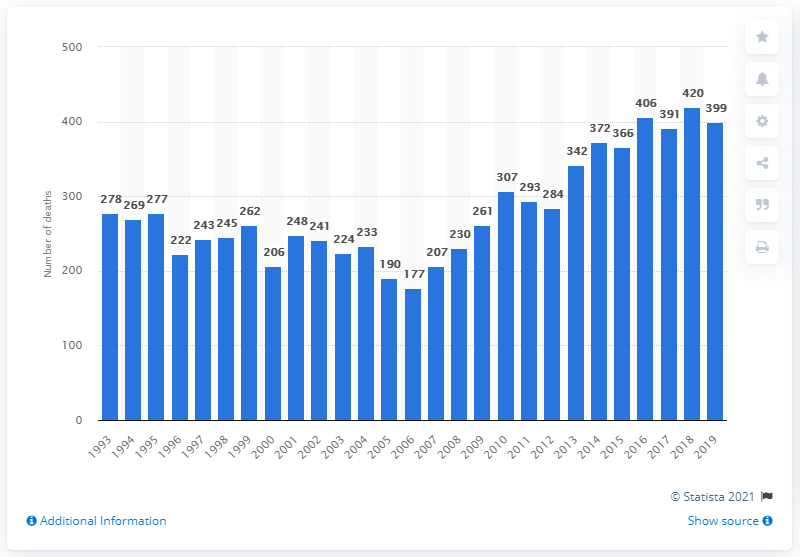Give some essential details in this illustration. In 2019, there were 399 deaths in England and Wales that were related to benzodiazepine use. 